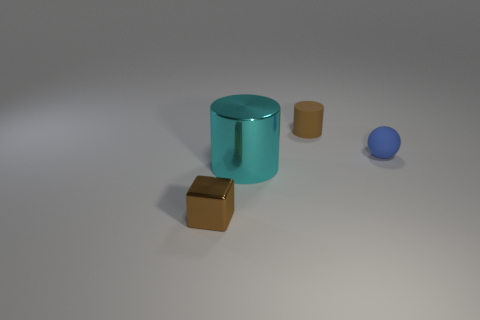Add 3 metal objects. How many objects exist? 7 Subtract all spheres. How many objects are left? 3 Subtract 2 cylinders. How many cylinders are left? 0 Subtract all blue cylinders. Subtract all cyan blocks. How many cylinders are left? 2 Subtract all cyan cubes. How many purple spheres are left? 0 Subtract all small brown blocks. Subtract all metallic blocks. How many objects are left? 2 Add 1 big objects. How many big objects are left? 2 Add 4 big cyan cylinders. How many big cyan cylinders exist? 5 Subtract all brown cylinders. How many cylinders are left? 1 Subtract 0 yellow cylinders. How many objects are left? 4 